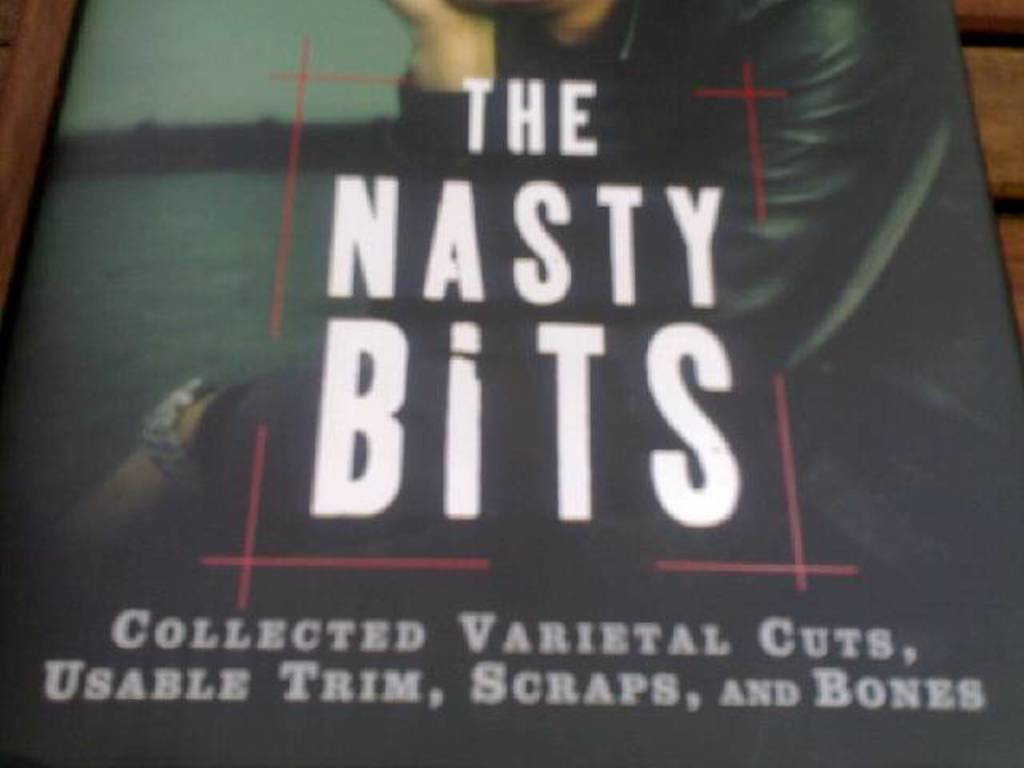What object can be seen in the image? There is a book in the image. What is the book placed on? The book is on a wooden surface. What words are written on the book? The words "the nasty bits" are written on the book. What type of stamp can be seen on the book in the image? There is no stamp visible on the book in the image. How does the book help with the treatment of a cold in the image? The book does not provide any treatment for a cold, as it is titled "the nasty bits." 